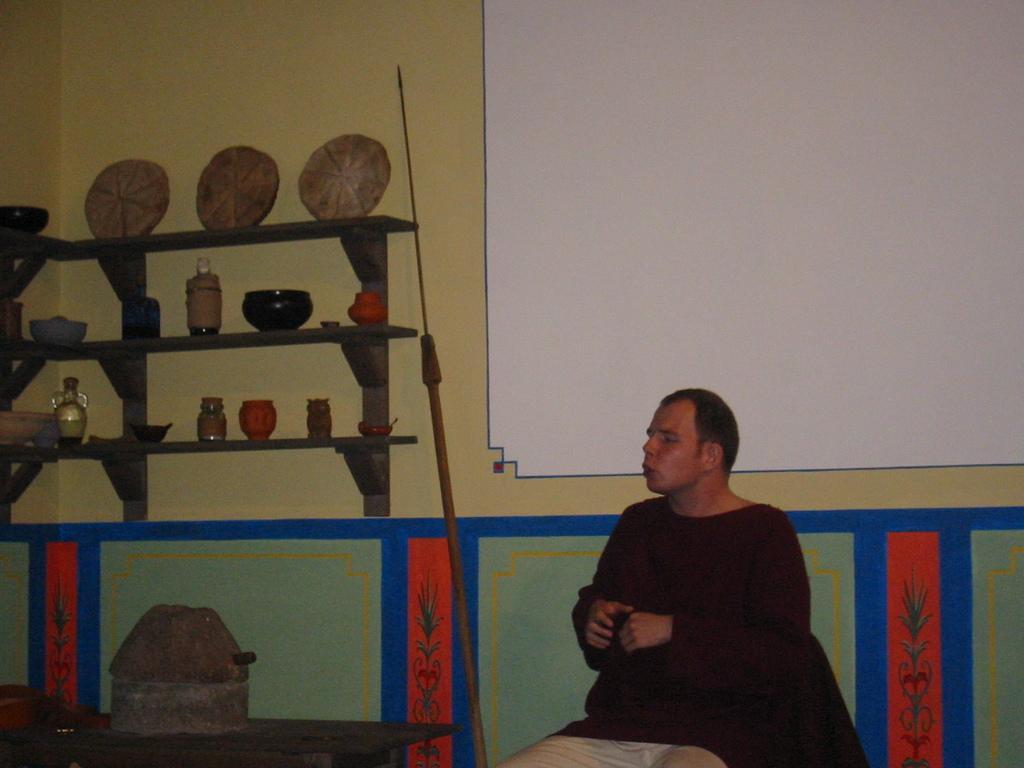How would you summarize this image in a sentence or two? In this picture I can see a man seated and I can see few bottles, bowls in the shelves and looks like a vessel on the table. 